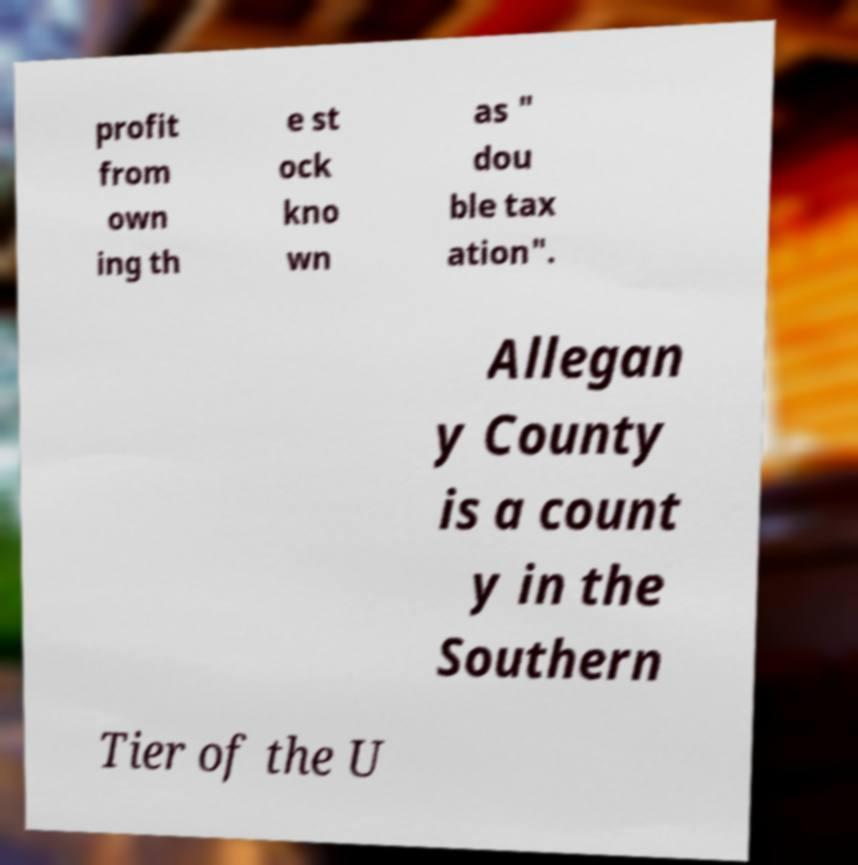Please identify and transcribe the text found in this image. profit from own ing th e st ock kno wn as " dou ble tax ation". Allegan y County is a count y in the Southern Tier of the U 